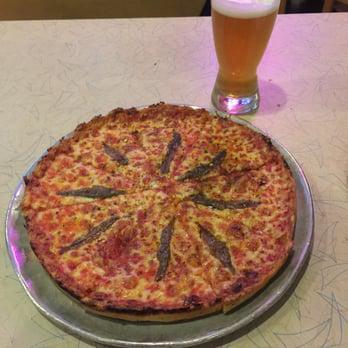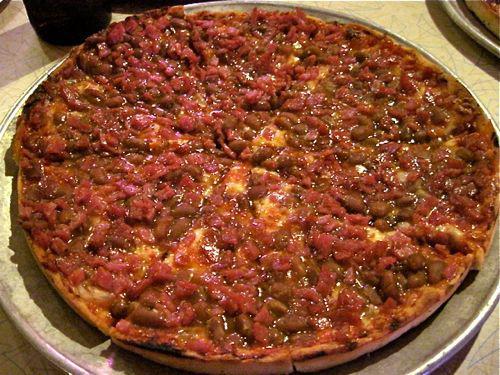The first image is the image on the left, the second image is the image on the right. Analyze the images presented: Is the assertion "All of the pizzas are whole without any pieces missing." valid? Answer yes or no. Yes. The first image is the image on the left, the second image is the image on the right. For the images shown, is this caption "The left image shows a round sliced pizza in a round pan with an empty space where two slices would fit, and does not show any other pans of pizza." true? Answer yes or no. No. 